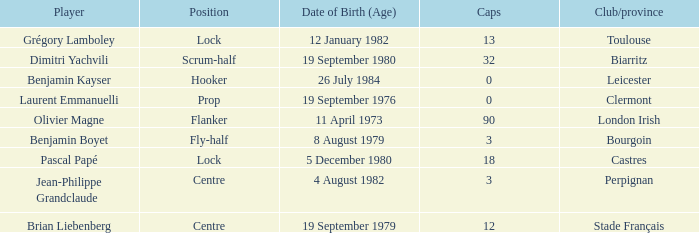What is the position of Perpignan? Centre. 